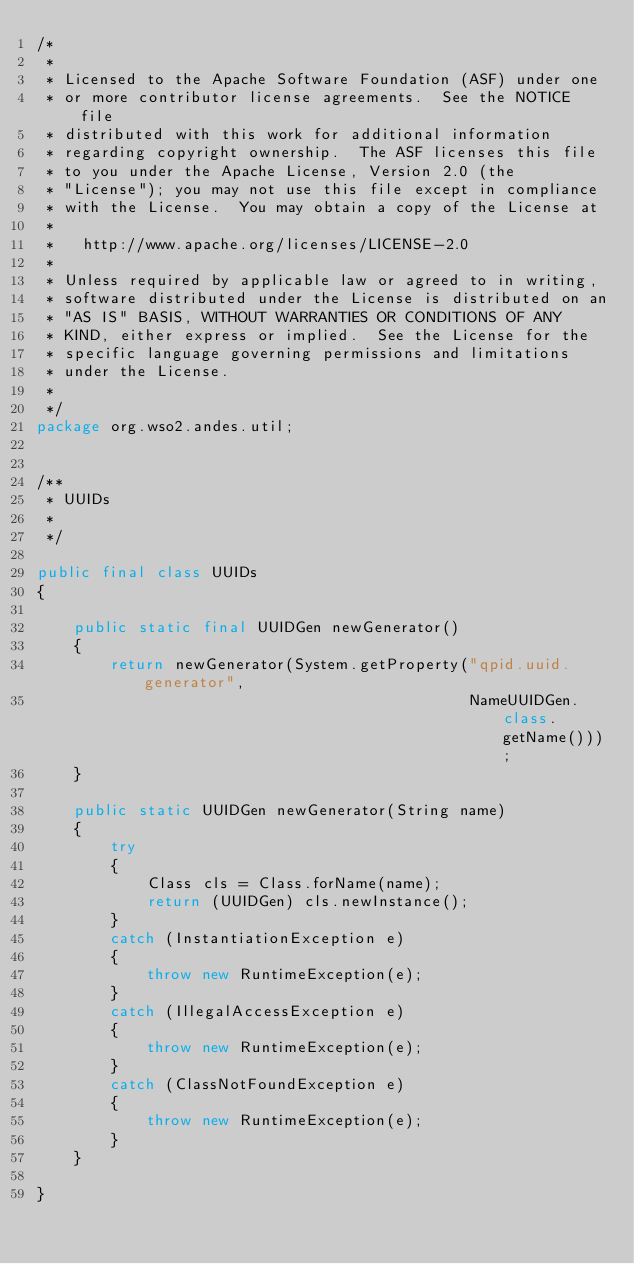Convert code to text. <code><loc_0><loc_0><loc_500><loc_500><_Java_>/*
 *
 * Licensed to the Apache Software Foundation (ASF) under one
 * or more contributor license agreements.  See the NOTICE file
 * distributed with this work for additional information
 * regarding copyright ownership.  The ASF licenses this file
 * to you under the Apache License, Version 2.0 (the
 * "License"); you may not use this file except in compliance
 * with the License.  You may obtain a copy of the License at
 *
 *   http://www.apache.org/licenses/LICENSE-2.0
 *
 * Unless required by applicable law or agreed to in writing,
 * software distributed under the License is distributed on an
 * "AS IS" BASIS, WITHOUT WARRANTIES OR CONDITIONS OF ANY
 * KIND, either express or implied.  See the License for the
 * specific language governing permissions and limitations
 * under the License.
 *
 */
package org.wso2.andes.util;


/**
 * UUIDs
 *
 */

public final class UUIDs
{

    public static final UUIDGen newGenerator()
    {
        return newGenerator(System.getProperty("qpid.uuid.generator",
                                               NameUUIDGen.class.getName()));
    }

    public static UUIDGen newGenerator(String name)
    {
        try
        {
            Class cls = Class.forName(name);
            return (UUIDGen) cls.newInstance();
        }
        catch (InstantiationException e)
        {
            throw new RuntimeException(e);
        }
        catch (IllegalAccessException e)
        {
            throw new RuntimeException(e);
        }
        catch (ClassNotFoundException e)
        {
            throw new RuntimeException(e);
        }
    }

}
</code> 